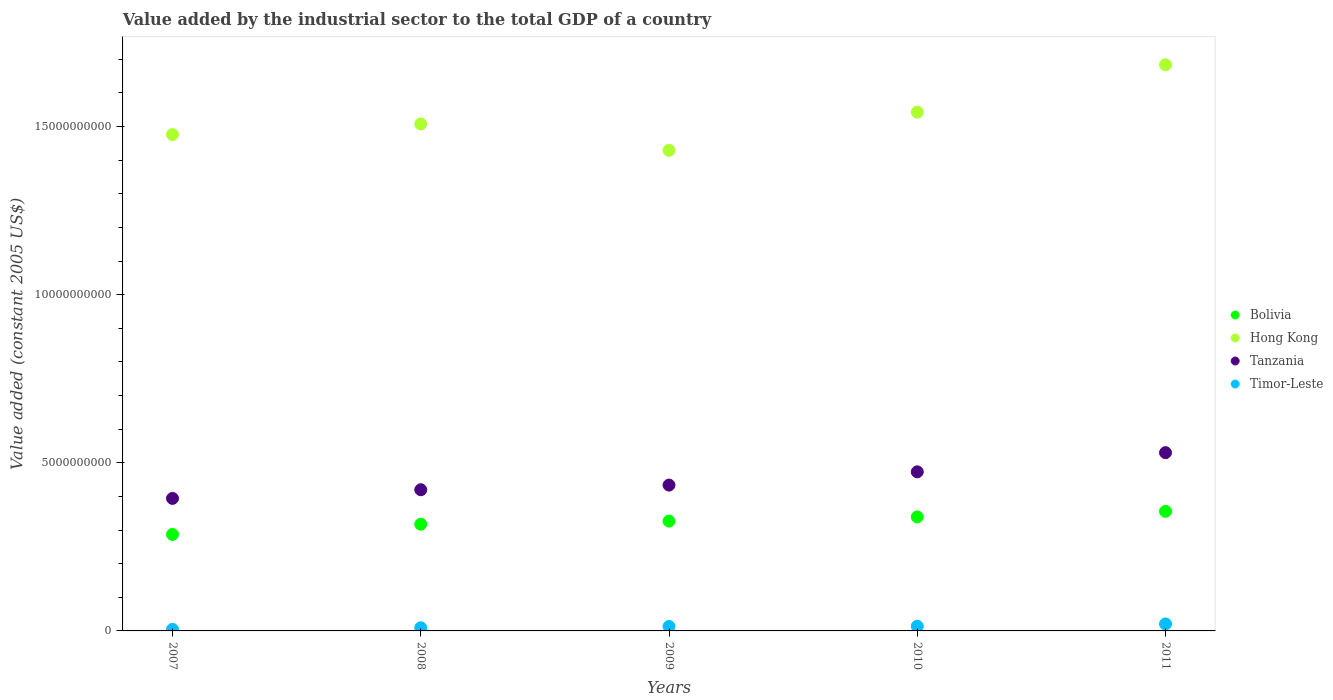How many different coloured dotlines are there?
Your answer should be compact. 4. What is the value added by the industrial sector in Tanzania in 2009?
Provide a short and direct response. 4.34e+09. Across all years, what is the maximum value added by the industrial sector in Bolivia?
Provide a short and direct response. 3.56e+09. Across all years, what is the minimum value added by the industrial sector in Bolivia?
Offer a very short reply. 2.87e+09. What is the total value added by the industrial sector in Bolivia in the graph?
Provide a short and direct response. 1.63e+1. What is the difference between the value added by the industrial sector in Tanzania in 2007 and that in 2008?
Offer a very short reply. -2.57e+08. What is the difference between the value added by the industrial sector in Hong Kong in 2010 and the value added by the industrial sector in Bolivia in 2009?
Give a very brief answer. 1.22e+1. What is the average value added by the industrial sector in Bolivia per year?
Offer a terse response. 3.25e+09. In the year 2009, what is the difference between the value added by the industrial sector in Timor-Leste and value added by the industrial sector in Bolivia?
Make the answer very short. -3.13e+09. In how many years, is the value added by the industrial sector in Tanzania greater than 5000000000 US$?
Provide a short and direct response. 1. What is the ratio of the value added by the industrial sector in Bolivia in 2007 to that in 2011?
Your response must be concise. 0.81. What is the difference between the highest and the second highest value added by the industrial sector in Bolivia?
Offer a very short reply. 1.65e+08. What is the difference between the highest and the lowest value added by the industrial sector in Timor-Leste?
Make the answer very short. 1.62e+08. In how many years, is the value added by the industrial sector in Timor-Leste greater than the average value added by the industrial sector in Timor-Leste taken over all years?
Your answer should be very brief. 3. Is the sum of the value added by the industrial sector in Timor-Leste in 2007 and 2008 greater than the maximum value added by the industrial sector in Tanzania across all years?
Your response must be concise. No. Is it the case that in every year, the sum of the value added by the industrial sector in Timor-Leste and value added by the industrial sector in Bolivia  is greater than the value added by the industrial sector in Hong Kong?
Ensure brevity in your answer.  No. Does the value added by the industrial sector in Hong Kong monotonically increase over the years?
Keep it short and to the point. No. How many dotlines are there?
Offer a terse response. 4. How many years are there in the graph?
Offer a terse response. 5. Where does the legend appear in the graph?
Offer a very short reply. Center right. How many legend labels are there?
Your response must be concise. 4. How are the legend labels stacked?
Keep it short and to the point. Vertical. What is the title of the graph?
Provide a short and direct response. Value added by the industrial sector to the total GDP of a country. What is the label or title of the Y-axis?
Offer a very short reply. Value added (constant 2005 US$). What is the Value added (constant 2005 US$) of Bolivia in 2007?
Keep it short and to the point. 2.87e+09. What is the Value added (constant 2005 US$) of Hong Kong in 2007?
Keep it short and to the point. 1.48e+1. What is the Value added (constant 2005 US$) of Tanzania in 2007?
Your answer should be very brief. 3.94e+09. What is the Value added (constant 2005 US$) of Timor-Leste in 2007?
Your answer should be very brief. 4.62e+07. What is the Value added (constant 2005 US$) of Bolivia in 2008?
Your answer should be very brief. 3.17e+09. What is the Value added (constant 2005 US$) in Hong Kong in 2008?
Provide a succinct answer. 1.51e+1. What is the Value added (constant 2005 US$) of Tanzania in 2008?
Ensure brevity in your answer.  4.20e+09. What is the Value added (constant 2005 US$) of Timor-Leste in 2008?
Your answer should be compact. 9.40e+07. What is the Value added (constant 2005 US$) in Bolivia in 2009?
Your answer should be very brief. 3.27e+09. What is the Value added (constant 2005 US$) in Hong Kong in 2009?
Provide a succinct answer. 1.43e+1. What is the Value added (constant 2005 US$) in Tanzania in 2009?
Your answer should be compact. 4.34e+09. What is the Value added (constant 2005 US$) in Timor-Leste in 2009?
Ensure brevity in your answer.  1.33e+08. What is the Value added (constant 2005 US$) of Bolivia in 2010?
Your response must be concise. 3.39e+09. What is the Value added (constant 2005 US$) in Hong Kong in 2010?
Offer a terse response. 1.54e+1. What is the Value added (constant 2005 US$) in Tanzania in 2010?
Your answer should be very brief. 4.73e+09. What is the Value added (constant 2005 US$) of Timor-Leste in 2010?
Offer a terse response. 1.39e+08. What is the Value added (constant 2005 US$) of Bolivia in 2011?
Offer a terse response. 3.56e+09. What is the Value added (constant 2005 US$) of Hong Kong in 2011?
Ensure brevity in your answer.  1.68e+1. What is the Value added (constant 2005 US$) in Tanzania in 2011?
Your answer should be very brief. 5.30e+09. What is the Value added (constant 2005 US$) in Timor-Leste in 2011?
Provide a short and direct response. 2.08e+08. Across all years, what is the maximum Value added (constant 2005 US$) in Bolivia?
Your response must be concise. 3.56e+09. Across all years, what is the maximum Value added (constant 2005 US$) in Hong Kong?
Ensure brevity in your answer.  1.68e+1. Across all years, what is the maximum Value added (constant 2005 US$) in Tanzania?
Give a very brief answer. 5.30e+09. Across all years, what is the maximum Value added (constant 2005 US$) of Timor-Leste?
Offer a terse response. 2.08e+08. Across all years, what is the minimum Value added (constant 2005 US$) of Bolivia?
Keep it short and to the point. 2.87e+09. Across all years, what is the minimum Value added (constant 2005 US$) of Hong Kong?
Provide a succinct answer. 1.43e+1. Across all years, what is the minimum Value added (constant 2005 US$) of Tanzania?
Offer a very short reply. 3.94e+09. Across all years, what is the minimum Value added (constant 2005 US$) of Timor-Leste?
Keep it short and to the point. 4.62e+07. What is the total Value added (constant 2005 US$) of Bolivia in the graph?
Your response must be concise. 1.63e+1. What is the total Value added (constant 2005 US$) in Hong Kong in the graph?
Your answer should be very brief. 7.64e+1. What is the total Value added (constant 2005 US$) in Tanzania in the graph?
Keep it short and to the point. 2.25e+1. What is the total Value added (constant 2005 US$) in Timor-Leste in the graph?
Give a very brief answer. 6.20e+08. What is the difference between the Value added (constant 2005 US$) of Bolivia in 2007 and that in 2008?
Ensure brevity in your answer.  -3.04e+08. What is the difference between the Value added (constant 2005 US$) of Hong Kong in 2007 and that in 2008?
Offer a terse response. -3.16e+08. What is the difference between the Value added (constant 2005 US$) of Tanzania in 2007 and that in 2008?
Give a very brief answer. -2.57e+08. What is the difference between the Value added (constant 2005 US$) in Timor-Leste in 2007 and that in 2008?
Your answer should be very brief. -4.78e+07. What is the difference between the Value added (constant 2005 US$) in Bolivia in 2007 and that in 2009?
Give a very brief answer. -3.96e+08. What is the difference between the Value added (constant 2005 US$) of Hong Kong in 2007 and that in 2009?
Ensure brevity in your answer.  4.69e+08. What is the difference between the Value added (constant 2005 US$) of Tanzania in 2007 and that in 2009?
Offer a terse response. -3.96e+08. What is the difference between the Value added (constant 2005 US$) of Timor-Leste in 2007 and that in 2009?
Give a very brief answer. -8.64e+07. What is the difference between the Value added (constant 2005 US$) in Bolivia in 2007 and that in 2010?
Offer a very short reply. -5.21e+08. What is the difference between the Value added (constant 2005 US$) in Hong Kong in 2007 and that in 2010?
Your answer should be very brief. -6.68e+08. What is the difference between the Value added (constant 2005 US$) of Tanzania in 2007 and that in 2010?
Provide a succinct answer. -7.90e+08. What is the difference between the Value added (constant 2005 US$) of Timor-Leste in 2007 and that in 2010?
Offer a very short reply. -9.32e+07. What is the difference between the Value added (constant 2005 US$) in Bolivia in 2007 and that in 2011?
Provide a short and direct response. -6.86e+08. What is the difference between the Value added (constant 2005 US$) of Hong Kong in 2007 and that in 2011?
Keep it short and to the point. -2.08e+09. What is the difference between the Value added (constant 2005 US$) of Tanzania in 2007 and that in 2011?
Provide a short and direct response. -1.36e+09. What is the difference between the Value added (constant 2005 US$) in Timor-Leste in 2007 and that in 2011?
Offer a very short reply. -1.62e+08. What is the difference between the Value added (constant 2005 US$) of Bolivia in 2008 and that in 2009?
Your answer should be very brief. -9.19e+07. What is the difference between the Value added (constant 2005 US$) in Hong Kong in 2008 and that in 2009?
Give a very brief answer. 7.85e+08. What is the difference between the Value added (constant 2005 US$) of Tanzania in 2008 and that in 2009?
Offer a terse response. -1.39e+08. What is the difference between the Value added (constant 2005 US$) of Timor-Leste in 2008 and that in 2009?
Give a very brief answer. -3.86e+07. What is the difference between the Value added (constant 2005 US$) of Bolivia in 2008 and that in 2010?
Make the answer very short. -2.17e+08. What is the difference between the Value added (constant 2005 US$) of Hong Kong in 2008 and that in 2010?
Ensure brevity in your answer.  -3.52e+08. What is the difference between the Value added (constant 2005 US$) in Tanzania in 2008 and that in 2010?
Keep it short and to the point. -5.33e+08. What is the difference between the Value added (constant 2005 US$) in Timor-Leste in 2008 and that in 2010?
Your response must be concise. -4.53e+07. What is the difference between the Value added (constant 2005 US$) in Bolivia in 2008 and that in 2011?
Give a very brief answer. -3.82e+08. What is the difference between the Value added (constant 2005 US$) of Hong Kong in 2008 and that in 2011?
Give a very brief answer. -1.76e+09. What is the difference between the Value added (constant 2005 US$) in Tanzania in 2008 and that in 2011?
Your answer should be compact. -1.10e+09. What is the difference between the Value added (constant 2005 US$) of Timor-Leste in 2008 and that in 2011?
Ensure brevity in your answer.  -1.14e+08. What is the difference between the Value added (constant 2005 US$) of Bolivia in 2009 and that in 2010?
Make the answer very short. -1.26e+08. What is the difference between the Value added (constant 2005 US$) in Hong Kong in 2009 and that in 2010?
Give a very brief answer. -1.14e+09. What is the difference between the Value added (constant 2005 US$) in Tanzania in 2009 and that in 2010?
Give a very brief answer. -3.94e+08. What is the difference between the Value added (constant 2005 US$) of Timor-Leste in 2009 and that in 2010?
Ensure brevity in your answer.  -6.71e+06. What is the difference between the Value added (constant 2005 US$) of Bolivia in 2009 and that in 2011?
Offer a very short reply. -2.91e+08. What is the difference between the Value added (constant 2005 US$) of Hong Kong in 2009 and that in 2011?
Your answer should be compact. -2.54e+09. What is the difference between the Value added (constant 2005 US$) of Tanzania in 2009 and that in 2011?
Offer a terse response. -9.64e+08. What is the difference between the Value added (constant 2005 US$) in Timor-Leste in 2009 and that in 2011?
Keep it short and to the point. -7.55e+07. What is the difference between the Value added (constant 2005 US$) of Bolivia in 2010 and that in 2011?
Ensure brevity in your answer.  -1.65e+08. What is the difference between the Value added (constant 2005 US$) of Hong Kong in 2010 and that in 2011?
Offer a terse response. -1.41e+09. What is the difference between the Value added (constant 2005 US$) of Tanzania in 2010 and that in 2011?
Provide a succinct answer. -5.70e+08. What is the difference between the Value added (constant 2005 US$) in Timor-Leste in 2010 and that in 2011?
Provide a succinct answer. -6.88e+07. What is the difference between the Value added (constant 2005 US$) of Bolivia in 2007 and the Value added (constant 2005 US$) of Hong Kong in 2008?
Offer a terse response. -1.22e+1. What is the difference between the Value added (constant 2005 US$) in Bolivia in 2007 and the Value added (constant 2005 US$) in Tanzania in 2008?
Offer a terse response. -1.33e+09. What is the difference between the Value added (constant 2005 US$) of Bolivia in 2007 and the Value added (constant 2005 US$) of Timor-Leste in 2008?
Offer a very short reply. 2.78e+09. What is the difference between the Value added (constant 2005 US$) in Hong Kong in 2007 and the Value added (constant 2005 US$) in Tanzania in 2008?
Keep it short and to the point. 1.06e+1. What is the difference between the Value added (constant 2005 US$) of Hong Kong in 2007 and the Value added (constant 2005 US$) of Timor-Leste in 2008?
Offer a terse response. 1.47e+1. What is the difference between the Value added (constant 2005 US$) of Tanzania in 2007 and the Value added (constant 2005 US$) of Timor-Leste in 2008?
Offer a terse response. 3.85e+09. What is the difference between the Value added (constant 2005 US$) of Bolivia in 2007 and the Value added (constant 2005 US$) of Hong Kong in 2009?
Provide a short and direct response. -1.14e+1. What is the difference between the Value added (constant 2005 US$) in Bolivia in 2007 and the Value added (constant 2005 US$) in Tanzania in 2009?
Provide a succinct answer. -1.47e+09. What is the difference between the Value added (constant 2005 US$) in Bolivia in 2007 and the Value added (constant 2005 US$) in Timor-Leste in 2009?
Provide a succinct answer. 2.74e+09. What is the difference between the Value added (constant 2005 US$) in Hong Kong in 2007 and the Value added (constant 2005 US$) in Tanzania in 2009?
Offer a terse response. 1.04e+1. What is the difference between the Value added (constant 2005 US$) of Hong Kong in 2007 and the Value added (constant 2005 US$) of Timor-Leste in 2009?
Your response must be concise. 1.46e+1. What is the difference between the Value added (constant 2005 US$) in Tanzania in 2007 and the Value added (constant 2005 US$) in Timor-Leste in 2009?
Your answer should be compact. 3.81e+09. What is the difference between the Value added (constant 2005 US$) of Bolivia in 2007 and the Value added (constant 2005 US$) of Hong Kong in 2010?
Provide a succinct answer. -1.26e+1. What is the difference between the Value added (constant 2005 US$) in Bolivia in 2007 and the Value added (constant 2005 US$) in Tanzania in 2010?
Offer a very short reply. -1.86e+09. What is the difference between the Value added (constant 2005 US$) in Bolivia in 2007 and the Value added (constant 2005 US$) in Timor-Leste in 2010?
Your answer should be very brief. 2.73e+09. What is the difference between the Value added (constant 2005 US$) in Hong Kong in 2007 and the Value added (constant 2005 US$) in Tanzania in 2010?
Ensure brevity in your answer.  1.00e+1. What is the difference between the Value added (constant 2005 US$) of Hong Kong in 2007 and the Value added (constant 2005 US$) of Timor-Leste in 2010?
Provide a succinct answer. 1.46e+1. What is the difference between the Value added (constant 2005 US$) of Tanzania in 2007 and the Value added (constant 2005 US$) of Timor-Leste in 2010?
Your answer should be very brief. 3.80e+09. What is the difference between the Value added (constant 2005 US$) of Bolivia in 2007 and the Value added (constant 2005 US$) of Hong Kong in 2011?
Offer a terse response. -1.40e+1. What is the difference between the Value added (constant 2005 US$) in Bolivia in 2007 and the Value added (constant 2005 US$) in Tanzania in 2011?
Ensure brevity in your answer.  -2.43e+09. What is the difference between the Value added (constant 2005 US$) of Bolivia in 2007 and the Value added (constant 2005 US$) of Timor-Leste in 2011?
Offer a terse response. 2.66e+09. What is the difference between the Value added (constant 2005 US$) of Hong Kong in 2007 and the Value added (constant 2005 US$) of Tanzania in 2011?
Offer a terse response. 9.46e+09. What is the difference between the Value added (constant 2005 US$) of Hong Kong in 2007 and the Value added (constant 2005 US$) of Timor-Leste in 2011?
Offer a very short reply. 1.46e+1. What is the difference between the Value added (constant 2005 US$) in Tanzania in 2007 and the Value added (constant 2005 US$) in Timor-Leste in 2011?
Your response must be concise. 3.73e+09. What is the difference between the Value added (constant 2005 US$) in Bolivia in 2008 and the Value added (constant 2005 US$) in Hong Kong in 2009?
Your answer should be compact. -1.11e+1. What is the difference between the Value added (constant 2005 US$) in Bolivia in 2008 and the Value added (constant 2005 US$) in Tanzania in 2009?
Your answer should be compact. -1.16e+09. What is the difference between the Value added (constant 2005 US$) in Bolivia in 2008 and the Value added (constant 2005 US$) in Timor-Leste in 2009?
Provide a short and direct response. 3.04e+09. What is the difference between the Value added (constant 2005 US$) in Hong Kong in 2008 and the Value added (constant 2005 US$) in Tanzania in 2009?
Your response must be concise. 1.07e+1. What is the difference between the Value added (constant 2005 US$) in Hong Kong in 2008 and the Value added (constant 2005 US$) in Timor-Leste in 2009?
Offer a terse response. 1.49e+1. What is the difference between the Value added (constant 2005 US$) of Tanzania in 2008 and the Value added (constant 2005 US$) of Timor-Leste in 2009?
Provide a short and direct response. 4.07e+09. What is the difference between the Value added (constant 2005 US$) of Bolivia in 2008 and the Value added (constant 2005 US$) of Hong Kong in 2010?
Offer a very short reply. -1.23e+1. What is the difference between the Value added (constant 2005 US$) in Bolivia in 2008 and the Value added (constant 2005 US$) in Tanzania in 2010?
Make the answer very short. -1.56e+09. What is the difference between the Value added (constant 2005 US$) in Bolivia in 2008 and the Value added (constant 2005 US$) in Timor-Leste in 2010?
Offer a terse response. 3.03e+09. What is the difference between the Value added (constant 2005 US$) in Hong Kong in 2008 and the Value added (constant 2005 US$) in Tanzania in 2010?
Your answer should be compact. 1.03e+1. What is the difference between the Value added (constant 2005 US$) of Hong Kong in 2008 and the Value added (constant 2005 US$) of Timor-Leste in 2010?
Provide a short and direct response. 1.49e+1. What is the difference between the Value added (constant 2005 US$) in Tanzania in 2008 and the Value added (constant 2005 US$) in Timor-Leste in 2010?
Provide a short and direct response. 4.06e+09. What is the difference between the Value added (constant 2005 US$) in Bolivia in 2008 and the Value added (constant 2005 US$) in Hong Kong in 2011?
Offer a terse response. -1.37e+1. What is the difference between the Value added (constant 2005 US$) in Bolivia in 2008 and the Value added (constant 2005 US$) in Tanzania in 2011?
Offer a very short reply. -2.13e+09. What is the difference between the Value added (constant 2005 US$) in Bolivia in 2008 and the Value added (constant 2005 US$) in Timor-Leste in 2011?
Provide a succinct answer. 2.97e+09. What is the difference between the Value added (constant 2005 US$) in Hong Kong in 2008 and the Value added (constant 2005 US$) in Tanzania in 2011?
Make the answer very short. 9.78e+09. What is the difference between the Value added (constant 2005 US$) of Hong Kong in 2008 and the Value added (constant 2005 US$) of Timor-Leste in 2011?
Offer a terse response. 1.49e+1. What is the difference between the Value added (constant 2005 US$) in Tanzania in 2008 and the Value added (constant 2005 US$) in Timor-Leste in 2011?
Your answer should be compact. 3.99e+09. What is the difference between the Value added (constant 2005 US$) of Bolivia in 2009 and the Value added (constant 2005 US$) of Hong Kong in 2010?
Your answer should be very brief. -1.22e+1. What is the difference between the Value added (constant 2005 US$) of Bolivia in 2009 and the Value added (constant 2005 US$) of Tanzania in 2010?
Keep it short and to the point. -1.47e+09. What is the difference between the Value added (constant 2005 US$) of Bolivia in 2009 and the Value added (constant 2005 US$) of Timor-Leste in 2010?
Give a very brief answer. 3.13e+09. What is the difference between the Value added (constant 2005 US$) in Hong Kong in 2009 and the Value added (constant 2005 US$) in Tanzania in 2010?
Your answer should be very brief. 9.56e+09. What is the difference between the Value added (constant 2005 US$) of Hong Kong in 2009 and the Value added (constant 2005 US$) of Timor-Leste in 2010?
Keep it short and to the point. 1.42e+1. What is the difference between the Value added (constant 2005 US$) of Tanzania in 2009 and the Value added (constant 2005 US$) of Timor-Leste in 2010?
Give a very brief answer. 4.20e+09. What is the difference between the Value added (constant 2005 US$) in Bolivia in 2009 and the Value added (constant 2005 US$) in Hong Kong in 2011?
Your response must be concise. -1.36e+1. What is the difference between the Value added (constant 2005 US$) of Bolivia in 2009 and the Value added (constant 2005 US$) of Tanzania in 2011?
Offer a terse response. -2.04e+09. What is the difference between the Value added (constant 2005 US$) in Bolivia in 2009 and the Value added (constant 2005 US$) in Timor-Leste in 2011?
Your answer should be compact. 3.06e+09. What is the difference between the Value added (constant 2005 US$) of Hong Kong in 2009 and the Value added (constant 2005 US$) of Tanzania in 2011?
Your answer should be compact. 8.99e+09. What is the difference between the Value added (constant 2005 US$) in Hong Kong in 2009 and the Value added (constant 2005 US$) in Timor-Leste in 2011?
Offer a very short reply. 1.41e+1. What is the difference between the Value added (constant 2005 US$) in Tanzania in 2009 and the Value added (constant 2005 US$) in Timor-Leste in 2011?
Your answer should be very brief. 4.13e+09. What is the difference between the Value added (constant 2005 US$) in Bolivia in 2010 and the Value added (constant 2005 US$) in Hong Kong in 2011?
Your response must be concise. -1.34e+1. What is the difference between the Value added (constant 2005 US$) of Bolivia in 2010 and the Value added (constant 2005 US$) of Tanzania in 2011?
Your response must be concise. -1.91e+09. What is the difference between the Value added (constant 2005 US$) in Bolivia in 2010 and the Value added (constant 2005 US$) in Timor-Leste in 2011?
Provide a short and direct response. 3.18e+09. What is the difference between the Value added (constant 2005 US$) of Hong Kong in 2010 and the Value added (constant 2005 US$) of Tanzania in 2011?
Keep it short and to the point. 1.01e+1. What is the difference between the Value added (constant 2005 US$) in Hong Kong in 2010 and the Value added (constant 2005 US$) in Timor-Leste in 2011?
Your response must be concise. 1.52e+1. What is the difference between the Value added (constant 2005 US$) of Tanzania in 2010 and the Value added (constant 2005 US$) of Timor-Leste in 2011?
Make the answer very short. 4.52e+09. What is the average Value added (constant 2005 US$) of Bolivia per year?
Offer a terse response. 3.25e+09. What is the average Value added (constant 2005 US$) of Hong Kong per year?
Provide a short and direct response. 1.53e+1. What is the average Value added (constant 2005 US$) in Tanzania per year?
Your answer should be very brief. 4.50e+09. What is the average Value added (constant 2005 US$) of Timor-Leste per year?
Provide a succinct answer. 1.24e+08. In the year 2007, what is the difference between the Value added (constant 2005 US$) in Bolivia and Value added (constant 2005 US$) in Hong Kong?
Provide a short and direct response. -1.19e+1. In the year 2007, what is the difference between the Value added (constant 2005 US$) in Bolivia and Value added (constant 2005 US$) in Tanzania?
Your answer should be compact. -1.07e+09. In the year 2007, what is the difference between the Value added (constant 2005 US$) of Bolivia and Value added (constant 2005 US$) of Timor-Leste?
Offer a terse response. 2.82e+09. In the year 2007, what is the difference between the Value added (constant 2005 US$) in Hong Kong and Value added (constant 2005 US$) in Tanzania?
Offer a terse response. 1.08e+1. In the year 2007, what is the difference between the Value added (constant 2005 US$) in Hong Kong and Value added (constant 2005 US$) in Timor-Leste?
Keep it short and to the point. 1.47e+1. In the year 2007, what is the difference between the Value added (constant 2005 US$) in Tanzania and Value added (constant 2005 US$) in Timor-Leste?
Ensure brevity in your answer.  3.90e+09. In the year 2008, what is the difference between the Value added (constant 2005 US$) of Bolivia and Value added (constant 2005 US$) of Hong Kong?
Give a very brief answer. -1.19e+1. In the year 2008, what is the difference between the Value added (constant 2005 US$) of Bolivia and Value added (constant 2005 US$) of Tanzania?
Offer a very short reply. -1.02e+09. In the year 2008, what is the difference between the Value added (constant 2005 US$) in Bolivia and Value added (constant 2005 US$) in Timor-Leste?
Ensure brevity in your answer.  3.08e+09. In the year 2008, what is the difference between the Value added (constant 2005 US$) of Hong Kong and Value added (constant 2005 US$) of Tanzania?
Your response must be concise. 1.09e+1. In the year 2008, what is the difference between the Value added (constant 2005 US$) of Hong Kong and Value added (constant 2005 US$) of Timor-Leste?
Your answer should be compact. 1.50e+1. In the year 2008, what is the difference between the Value added (constant 2005 US$) of Tanzania and Value added (constant 2005 US$) of Timor-Leste?
Provide a succinct answer. 4.10e+09. In the year 2009, what is the difference between the Value added (constant 2005 US$) in Bolivia and Value added (constant 2005 US$) in Hong Kong?
Your answer should be compact. -1.10e+1. In the year 2009, what is the difference between the Value added (constant 2005 US$) of Bolivia and Value added (constant 2005 US$) of Tanzania?
Offer a very short reply. -1.07e+09. In the year 2009, what is the difference between the Value added (constant 2005 US$) in Bolivia and Value added (constant 2005 US$) in Timor-Leste?
Offer a terse response. 3.13e+09. In the year 2009, what is the difference between the Value added (constant 2005 US$) of Hong Kong and Value added (constant 2005 US$) of Tanzania?
Your response must be concise. 9.96e+09. In the year 2009, what is the difference between the Value added (constant 2005 US$) in Hong Kong and Value added (constant 2005 US$) in Timor-Leste?
Your answer should be compact. 1.42e+1. In the year 2009, what is the difference between the Value added (constant 2005 US$) in Tanzania and Value added (constant 2005 US$) in Timor-Leste?
Your answer should be compact. 4.20e+09. In the year 2010, what is the difference between the Value added (constant 2005 US$) in Bolivia and Value added (constant 2005 US$) in Hong Kong?
Make the answer very short. -1.20e+1. In the year 2010, what is the difference between the Value added (constant 2005 US$) of Bolivia and Value added (constant 2005 US$) of Tanzania?
Give a very brief answer. -1.34e+09. In the year 2010, what is the difference between the Value added (constant 2005 US$) in Bolivia and Value added (constant 2005 US$) in Timor-Leste?
Your response must be concise. 3.25e+09. In the year 2010, what is the difference between the Value added (constant 2005 US$) in Hong Kong and Value added (constant 2005 US$) in Tanzania?
Your answer should be very brief. 1.07e+1. In the year 2010, what is the difference between the Value added (constant 2005 US$) in Hong Kong and Value added (constant 2005 US$) in Timor-Leste?
Ensure brevity in your answer.  1.53e+1. In the year 2010, what is the difference between the Value added (constant 2005 US$) in Tanzania and Value added (constant 2005 US$) in Timor-Leste?
Your answer should be very brief. 4.59e+09. In the year 2011, what is the difference between the Value added (constant 2005 US$) of Bolivia and Value added (constant 2005 US$) of Hong Kong?
Give a very brief answer. -1.33e+1. In the year 2011, what is the difference between the Value added (constant 2005 US$) in Bolivia and Value added (constant 2005 US$) in Tanzania?
Provide a succinct answer. -1.75e+09. In the year 2011, what is the difference between the Value added (constant 2005 US$) of Bolivia and Value added (constant 2005 US$) of Timor-Leste?
Provide a succinct answer. 3.35e+09. In the year 2011, what is the difference between the Value added (constant 2005 US$) in Hong Kong and Value added (constant 2005 US$) in Tanzania?
Your response must be concise. 1.15e+1. In the year 2011, what is the difference between the Value added (constant 2005 US$) in Hong Kong and Value added (constant 2005 US$) in Timor-Leste?
Your answer should be very brief. 1.66e+1. In the year 2011, what is the difference between the Value added (constant 2005 US$) in Tanzania and Value added (constant 2005 US$) in Timor-Leste?
Provide a succinct answer. 5.09e+09. What is the ratio of the Value added (constant 2005 US$) of Bolivia in 2007 to that in 2008?
Keep it short and to the point. 0.9. What is the ratio of the Value added (constant 2005 US$) of Hong Kong in 2007 to that in 2008?
Ensure brevity in your answer.  0.98. What is the ratio of the Value added (constant 2005 US$) in Tanzania in 2007 to that in 2008?
Give a very brief answer. 0.94. What is the ratio of the Value added (constant 2005 US$) of Timor-Leste in 2007 to that in 2008?
Your answer should be very brief. 0.49. What is the ratio of the Value added (constant 2005 US$) of Bolivia in 2007 to that in 2009?
Your answer should be compact. 0.88. What is the ratio of the Value added (constant 2005 US$) in Hong Kong in 2007 to that in 2009?
Provide a succinct answer. 1.03. What is the ratio of the Value added (constant 2005 US$) in Tanzania in 2007 to that in 2009?
Your answer should be compact. 0.91. What is the ratio of the Value added (constant 2005 US$) of Timor-Leste in 2007 to that in 2009?
Offer a terse response. 0.35. What is the ratio of the Value added (constant 2005 US$) in Bolivia in 2007 to that in 2010?
Make the answer very short. 0.85. What is the ratio of the Value added (constant 2005 US$) of Hong Kong in 2007 to that in 2010?
Make the answer very short. 0.96. What is the ratio of the Value added (constant 2005 US$) of Tanzania in 2007 to that in 2010?
Ensure brevity in your answer.  0.83. What is the ratio of the Value added (constant 2005 US$) in Timor-Leste in 2007 to that in 2010?
Provide a succinct answer. 0.33. What is the ratio of the Value added (constant 2005 US$) in Bolivia in 2007 to that in 2011?
Your response must be concise. 0.81. What is the ratio of the Value added (constant 2005 US$) of Hong Kong in 2007 to that in 2011?
Offer a terse response. 0.88. What is the ratio of the Value added (constant 2005 US$) of Tanzania in 2007 to that in 2011?
Keep it short and to the point. 0.74. What is the ratio of the Value added (constant 2005 US$) in Timor-Leste in 2007 to that in 2011?
Provide a short and direct response. 0.22. What is the ratio of the Value added (constant 2005 US$) in Bolivia in 2008 to that in 2009?
Make the answer very short. 0.97. What is the ratio of the Value added (constant 2005 US$) in Hong Kong in 2008 to that in 2009?
Ensure brevity in your answer.  1.05. What is the ratio of the Value added (constant 2005 US$) in Timor-Leste in 2008 to that in 2009?
Provide a short and direct response. 0.71. What is the ratio of the Value added (constant 2005 US$) in Bolivia in 2008 to that in 2010?
Provide a succinct answer. 0.94. What is the ratio of the Value added (constant 2005 US$) of Hong Kong in 2008 to that in 2010?
Keep it short and to the point. 0.98. What is the ratio of the Value added (constant 2005 US$) of Tanzania in 2008 to that in 2010?
Offer a terse response. 0.89. What is the ratio of the Value added (constant 2005 US$) in Timor-Leste in 2008 to that in 2010?
Make the answer very short. 0.67. What is the ratio of the Value added (constant 2005 US$) in Bolivia in 2008 to that in 2011?
Ensure brevity in your answer.  0.89. What is the ratio of the Value added (constant 2005 US$) of Hong Kong in 2008 to that in 2011?
Provide a short and direct response. 0.9. What is the ratio of the Value added (constant 2005 US$) of Tanzania in 2008 to that in 2011?
Offer a very short reply. 0.79. What is the ratio of the Value added (constant 2005 US$) in Timor-Leste in 2008 to that in 2011?
Offer a very short reply. 0.45. What is the ratio of the Value added (constant 2005 US$) of Bolivia in 2009 to that in 2010?
Keep it short and to the point. 0.96. What is the ratio of the Value added (constant 2005 US$) in Hong Kong in 2009 to that in 2010?
Offer a terse response. 0.93. What is the ratio of the Value added (constant 2005 US$) in Timor-Leste in 2009 to that in 2010?
Provide a short and direct response. 0.95. What is the ratio of the Value added (constant 2005 US$) of Bolivia in 2009 to that in 2011?
Offer a very short reply. 0.92. What is the ratio of the Value added (constant 2005 US$) of Hong Kong in 2009 to that in 2011?
Keep it short and to the point. 0.85. What is the ratio of the Value added (constant 2005 US$) in Tanzania in 2009 to that in 2011?
Your answer should be very brief. 0.82. What is the ratio of the Value added (constant 2005 US$) in Timor-Leste in 2009 to that in 2011?
Your answer should be compact. 0.64. What is the ratio of the Value added (constant 2005 US$) in Bolivia in 2010 to that in 2011?
Ensure brevity in your answer.  0.95. What is the ratio of the Value added (constant 2005 US$) in Hong Kong in 2010 to that in 2011?
Provide a short and direct response. 0.92. What is the ratio of the Value added (constant 2005 US$) in Tanzania in 2010 to that in 2011?
Provide a succinct answer. 0.89. What is the ratio of the Value added (constant 2005 US$) of Timor-Leste in 2010 to that in 2011?
Ensure brevity in your answer.  0.67. What is the difference between the highest and the second highest Value added (constant 2005 US$) of Bolivia?
Your answer should be compact. 1.65e+08. What is the difference between the highest and the second highest Value added (constant 2005 US$) of Hong Kong?
Your answer should be compact. 1.41e+09. What is the difference between the highest and the second highest Value added (constant 2005 US$) of Tanzania?
Your response must be concise. 5.70e+08. What is the difference between the highest and the second highest Value added (constant 2005 US$) of Timor-Leste?
Your answer should be compact. 6.88e+07. What is the difference between the highest and the lowest Value added (constant 2005 US$) of Bolivia?
Give a very brief answer. 6.86e+08. What is the difference between the highest and the lowest Value added (constant 2005 US$) in Hong Kong?
Keep it short and to the point. 2.54e+09. What is the difference between the highest and the lowest Value added (constant 2005 US$) of Tanzania?
Provide a short and direct response. 1.36e+09. What is the difference between the highest and the lowest Value added (constant 2005 US$) in Timor-Leste?
Your answer should be very brief. 1.62e+08. 